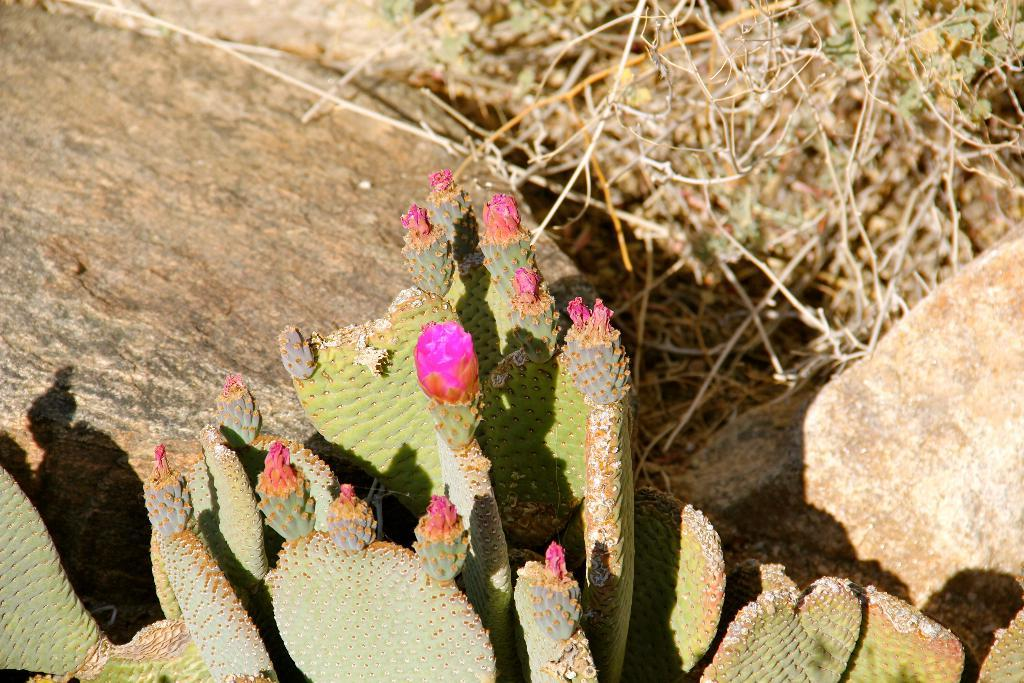What type of plants are featured in the image? There are cactus plants with flowers in the image. What can be seen behind the cactus plants? There are rocks and branches behind the cactus plants. What type of curtain is hanging in front of the cactus plants in the image? There is no curtain present in the image. 